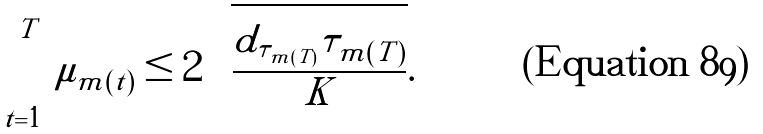Convert formula to latex. <formula><loc_0><loc_0><loc_500><loc_500>\sum _ { t = 1 } ^ { T } \mu _ { m ( t ) } \leq 2 \sqrt { \frac { d _ { \tau _ { m ( T ) } } \tau _ { m ( T ) } } { K } } .</formula> 